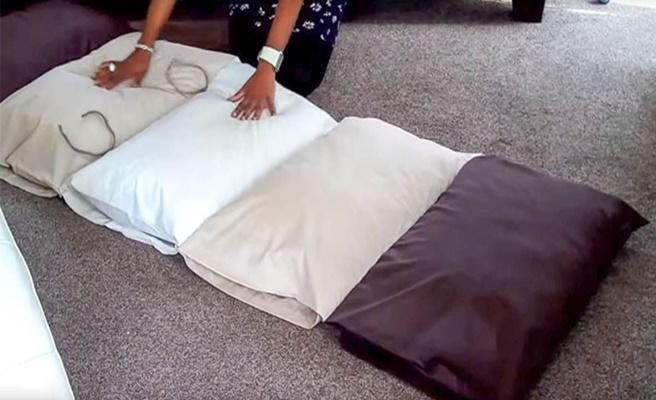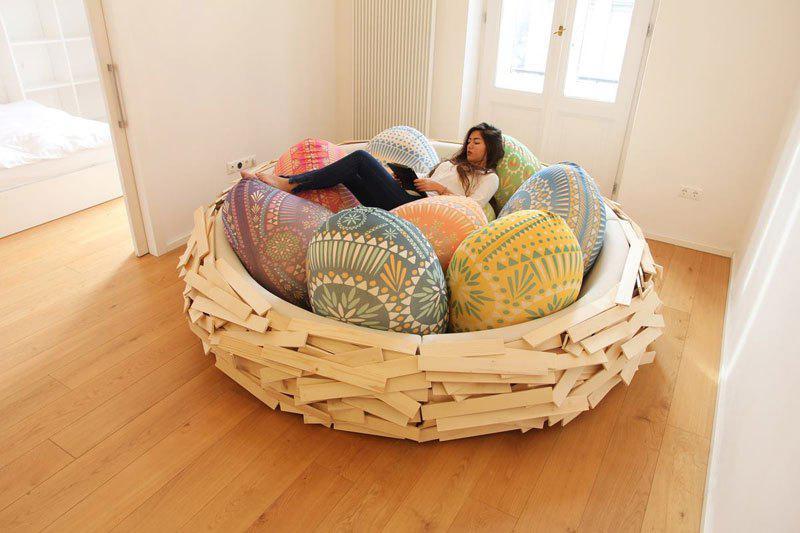The first image is the image on the left, the second image is the image on the right. Evaluate the accuracy of this statement regarding the images: "The left image includes two people on some type of cushioned surface, and the right image features at least one little girl lying on her stomach on a mat consisting of several pillow sections.". Is it true? Answer yes or no. No. The first image is the image on the left, the second image is the image on the right. Given the left and right images, does the statement "The right image contains two children." hold true? Answer yes or no. No. 